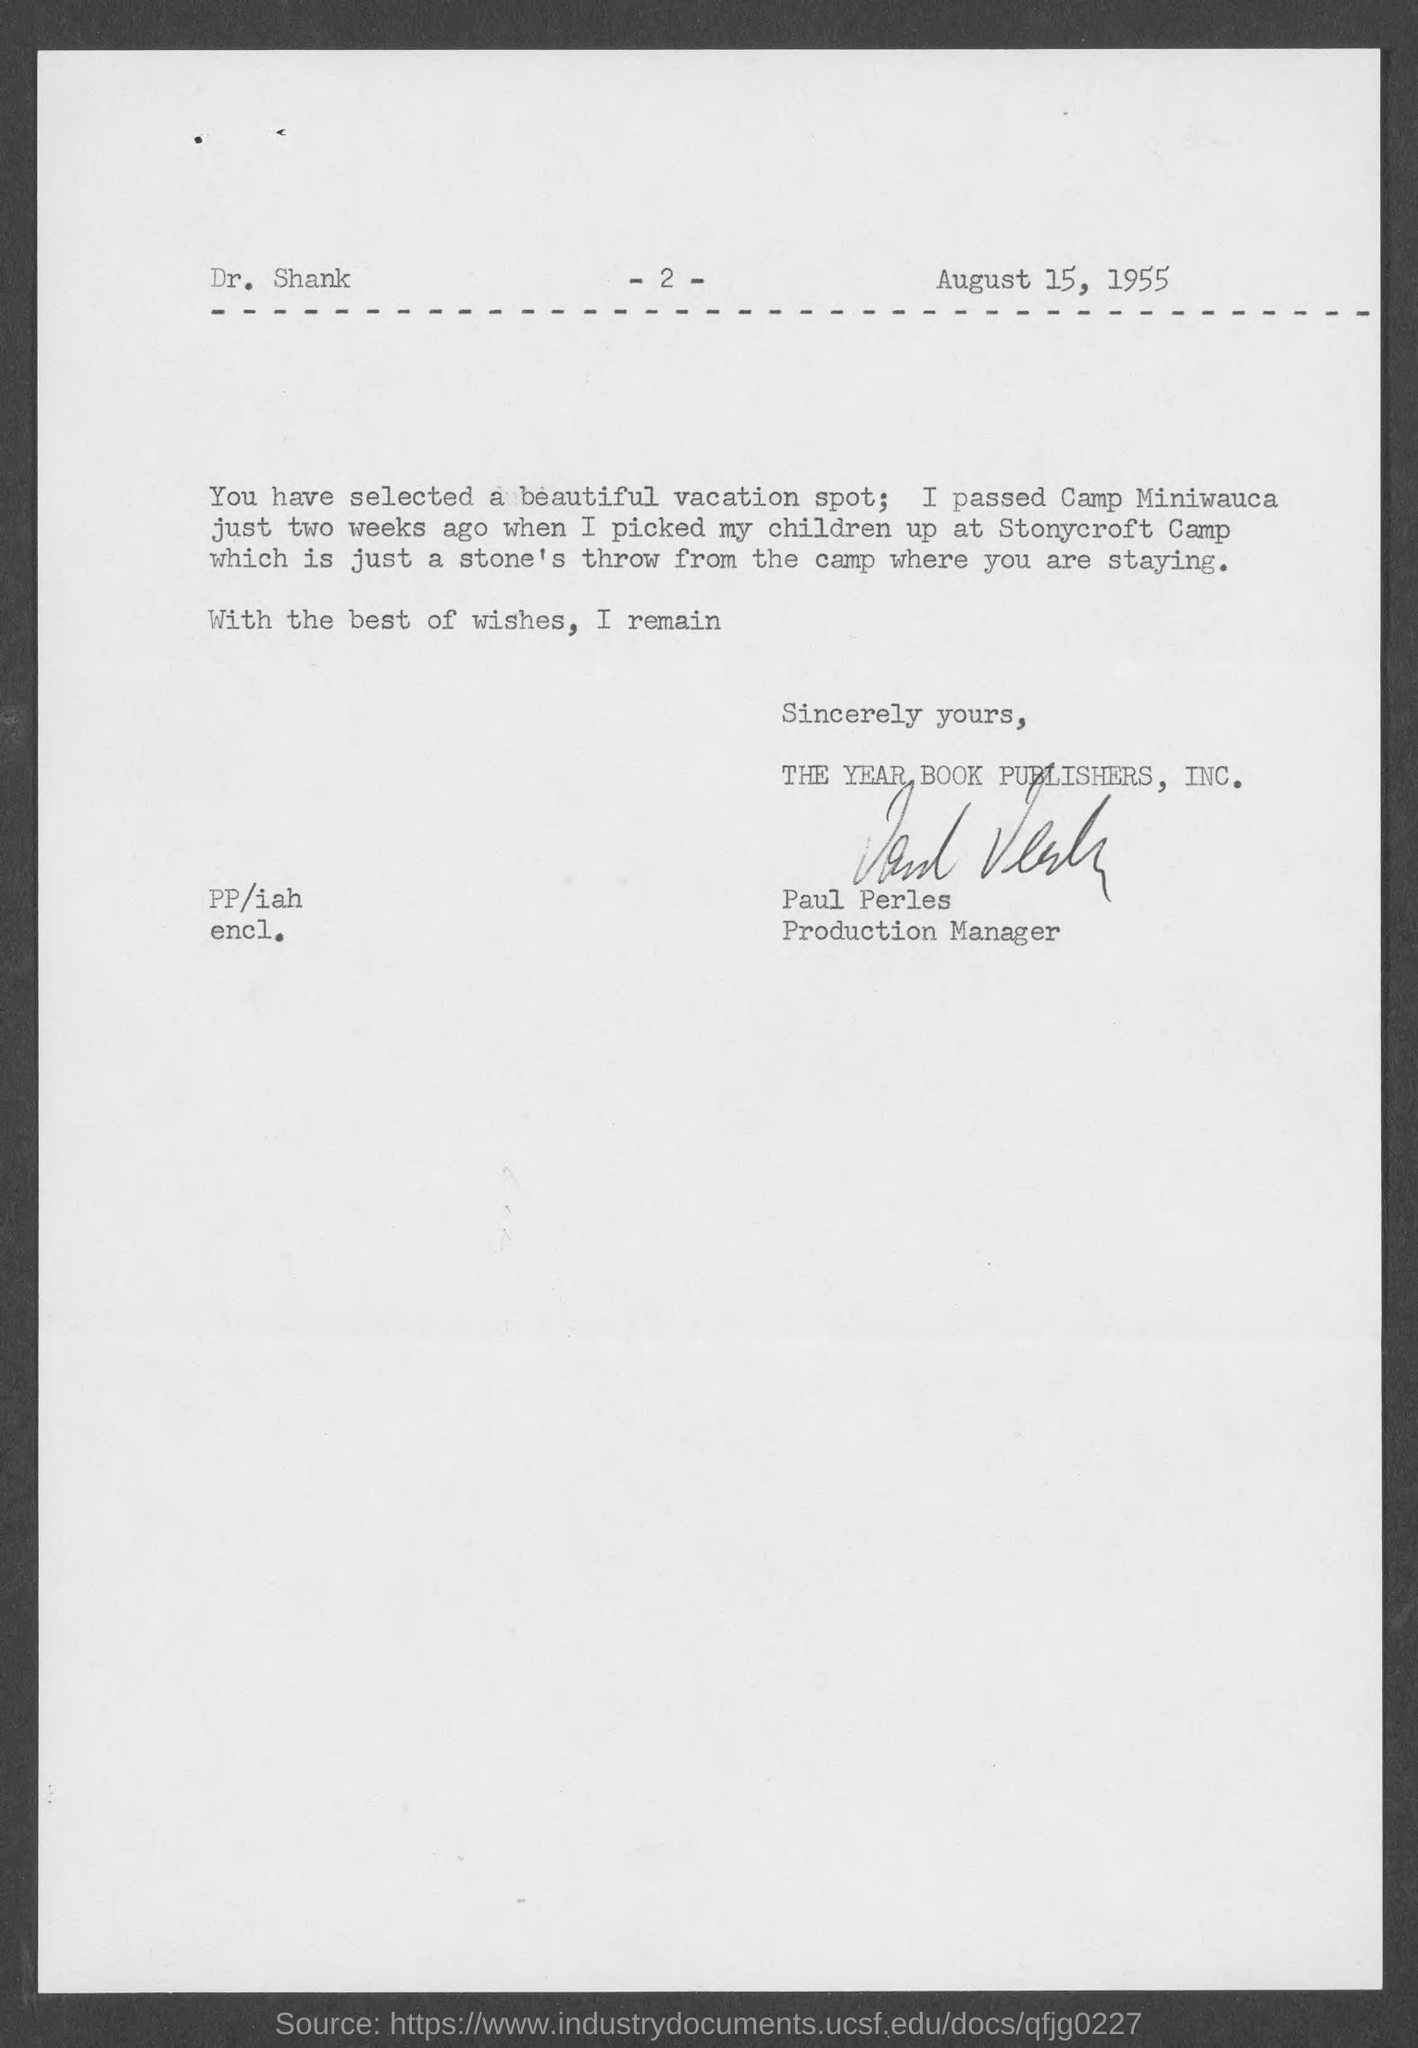Highlight a few significant elements in this photo. This letter is addressed to Dr. Shank. The date on the document is August 15, 1955. The letter is from Paul Perles. He passed two weeks ago at Camp Miniwauca. 